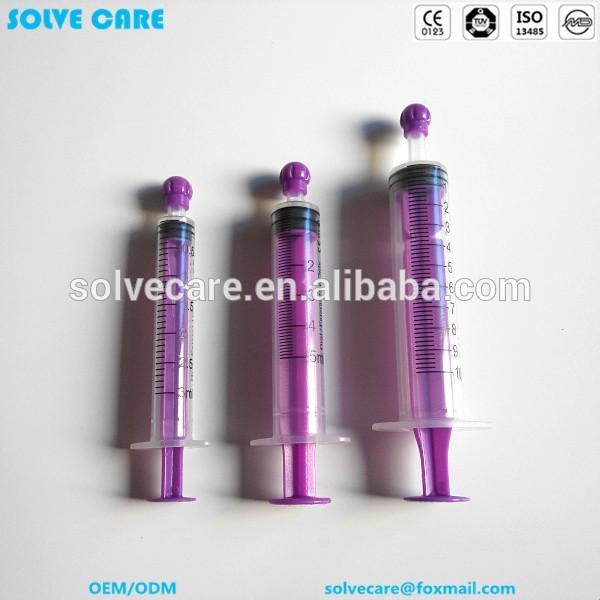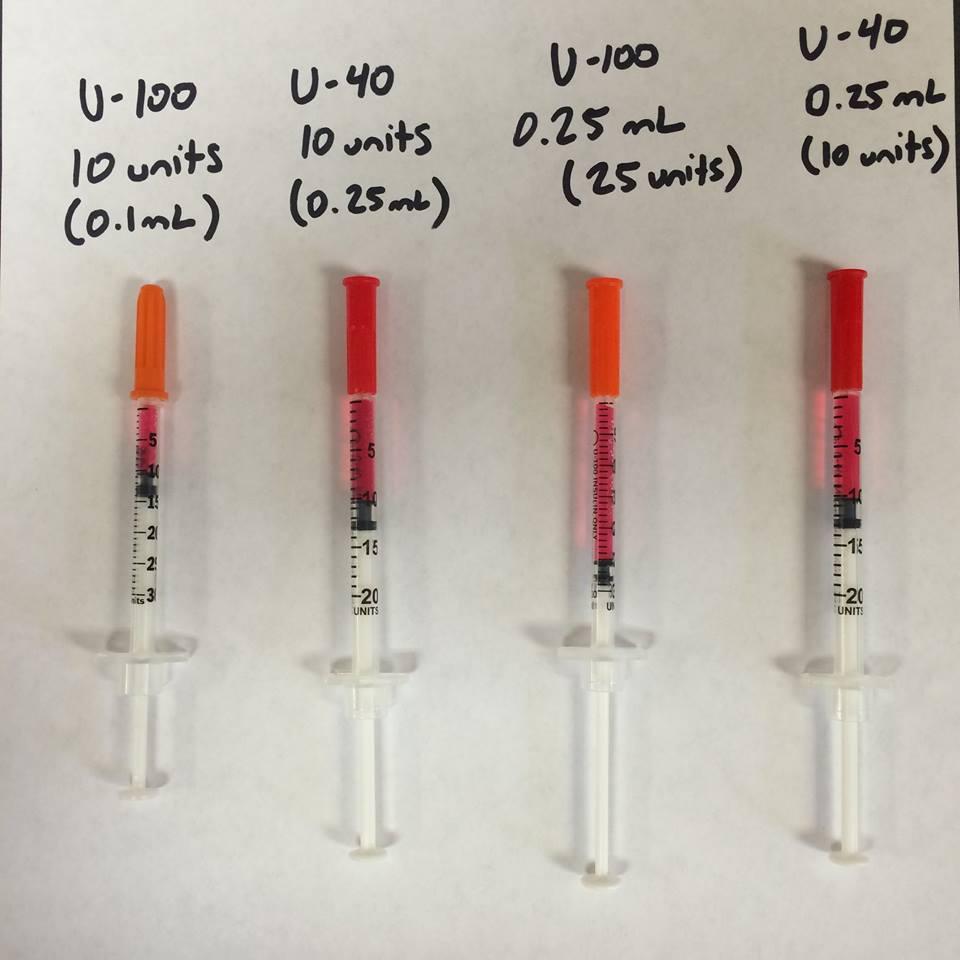The first image is the image on the left, the second image is the image on the right. Evaluate the accuracy of this statement regarding the images: "One of the images contains four syringes that appear to be red in color or fill.". Is it true? Answer yes or no. Yes. The first image is the image on the left, the second image is the image on the right. Assess this claim about the two images: "Atleast one of the images has 4 needles". Correct or not? Answer yes or no. Yes. 